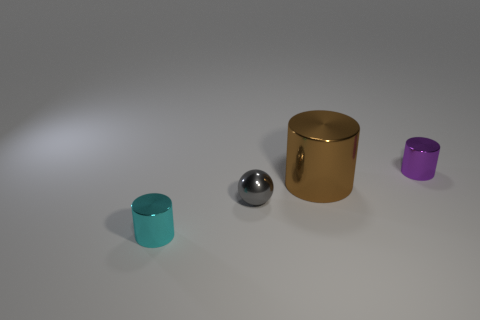Is there any other thing that has the same material as the cyan cylinder?
Your answer should be very brief. Yes. What number of objects are either large brown rubber objects or shiny things on the left side of the metal ball?
Ensure brevity in your answer.  1. Are there any things of the same color as the small shiny sphere?
Provide a short and direct response. No. How many blue things are tiny metal spheres or metal objects?
Your answer should be compact. 0. What number of other things are there of the same size as the brown cylinder?
Ensure brevity in your answer.  0. How many large objects are either brown shiny blocks or purple cylinders?
Provide a short and direct response. 0. Does the metal ball have the same size as the brown shiny cylinder behind the gray object?
Give a very brief answer. No. What number of other things are the same shape as the gray metal object?
Offer a terse response. 0. There is a gray thing that is the same material as the small purple cylinder; what is its shape?
Make the answer very short. Sphere. Are any cyan cylinders visible?
Keep it short and to the point. Yes. 